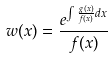Convert formula to latex. <formula><loc_0><loc_0><loc_500><loc_500>w ( x ) = \frac { e ^ { \int \frac { g ( x ) } { f ( x ) } d x } } { f ( x ) }</formula> 